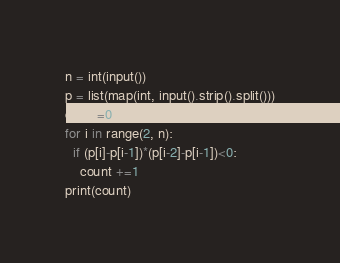Convert code to text. <code><loc_0><loc_0><loc_500><loc_500><_Python_>n = int(input())
p = list(map(int, input().strip().split()))
count=0
for i in range(2, n):
  if (p[i]-p[i-1])*(p[i-2]-p[i-1])<0:
    count +=1
print(count) </code> 